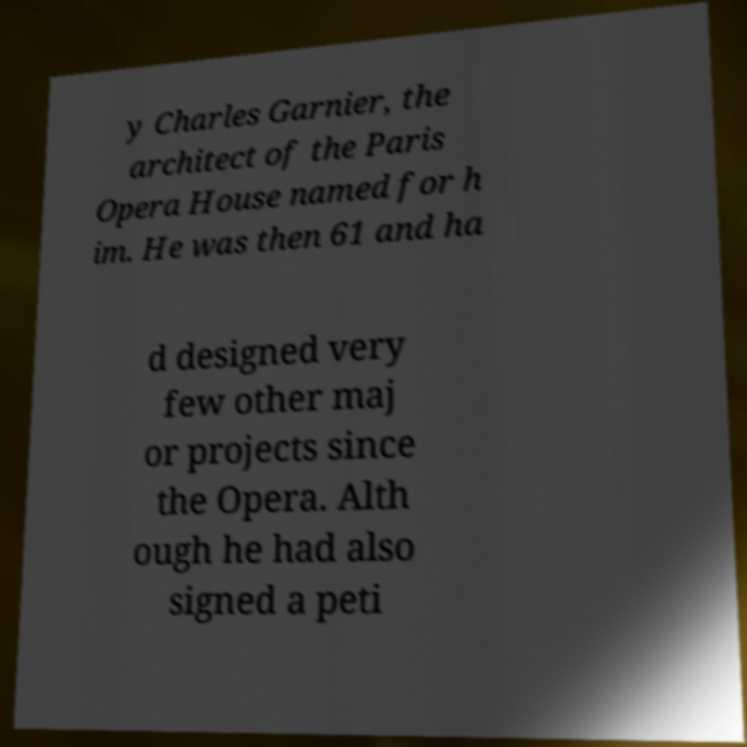Could you assist in decoding the text presented in this image and type it out clearly? y Charles Garnier, the architect of the Paris Opera House named for h im. He was then 61 and ha d designed very few other maj or projects since the Opera. Alth ough he had also signed a peti 